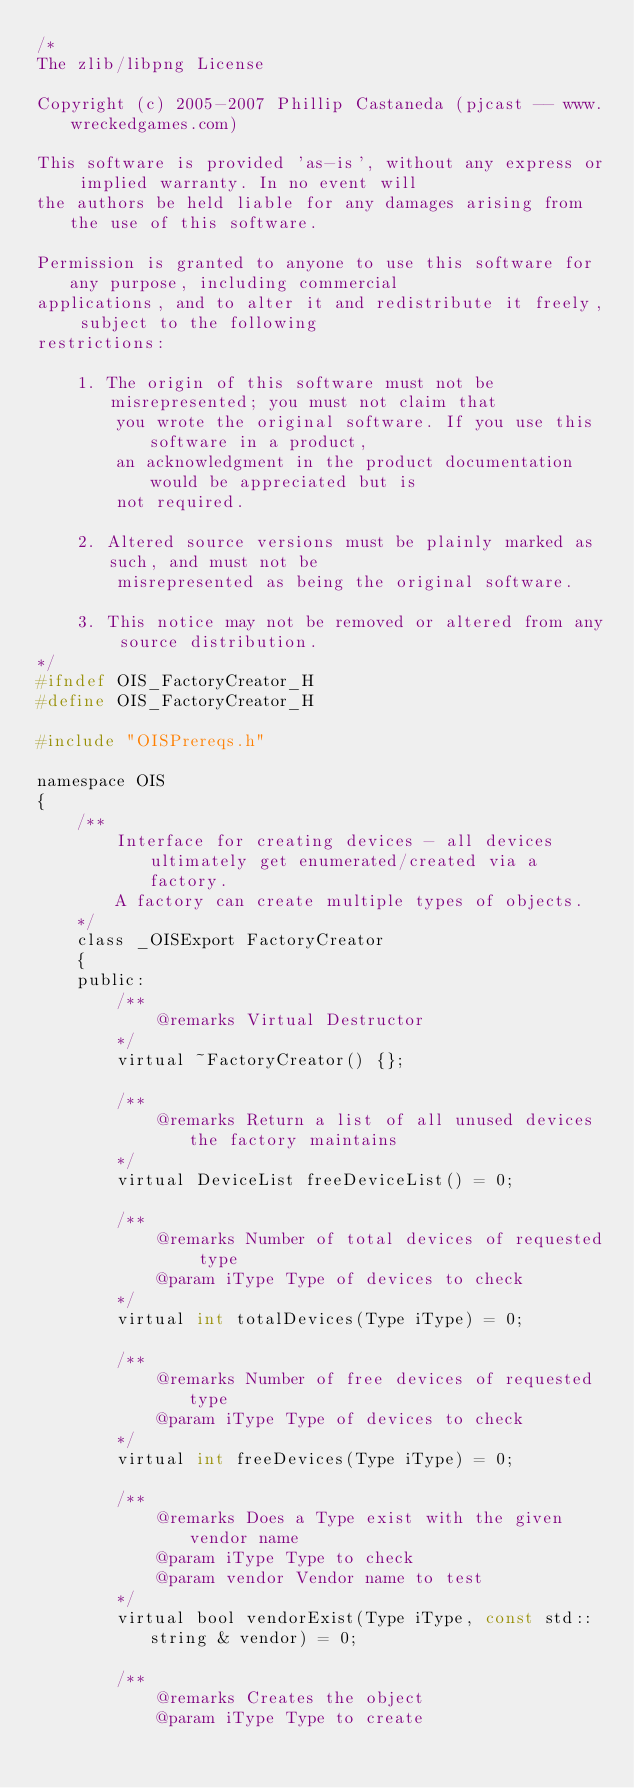Convert code to text. <code><loc_0><loc_0><loc_500><loc_500><_C_>/*
The zlib/libpng License

Copyright (c) 2005-2007 Phillip Castaneda (pjcast -- www.wreckedgames.com)

This software is provided 'as-is', without any express or implied warranty. In no event will
the authors be held liable for any damages arising from the use of this software.

Permission is granted to anyone to use this software for any purpose, including commercial 
applications, and to alter it and redistribute it freely, subject to the following
restrictions:

    1. The origin of this software must not be misrepresented; you must not claim that 
		you wrote the original software. If you use this software in a product, 
		an acknowledgment in the product documentation would be appreciated but is 
		not required.

    2. Altered source versions must be plainly marked as such, and must not be 
		misrepresented as being the original software.

    3. This notice may not be removed or altered from any source distribution.
*/
#ifndef OIS_FactoryCreator_H
#define OIS_FactoryCreator_H

#include "OISPrereqs.h"

namespace OIS
{
	/**
		Interface for creating devices - all devices ultimately get enumerated/created via a factory.
		A factory can create multiple types of objects.
	*/
	class _OISExport FactoryCreator
	{
	public:
		/**
			@remarks Virtual Destructor
		*/
		virtual ~FactoryCreator() {};

		/**
			@remarks Return a list of all unused devices the factory maintains
		*/
		virtual DeviceList freeDeviceList() = 0;

		/**
			@remarks Number of total devices of requested type
			@param iType Type of devices to check
		*/
		virtual int totalDevices(Type iType) = 0;

		/**
			@remarks Number of free devices of requested type
			@param iType Type of devices to check
		*/
		virtual int freeDevices(Type iType) = 0;

		/**
			@remarks Does a Type exist with the given vendor name
			@param iType Type to check
			@param vendor Vendor name to test
		*/
		virtual bool vendorExist(Type iType, const std::string & vendor) = 0;

		/**
			@remarks Creates the object
			@param iType Type to create</code> 